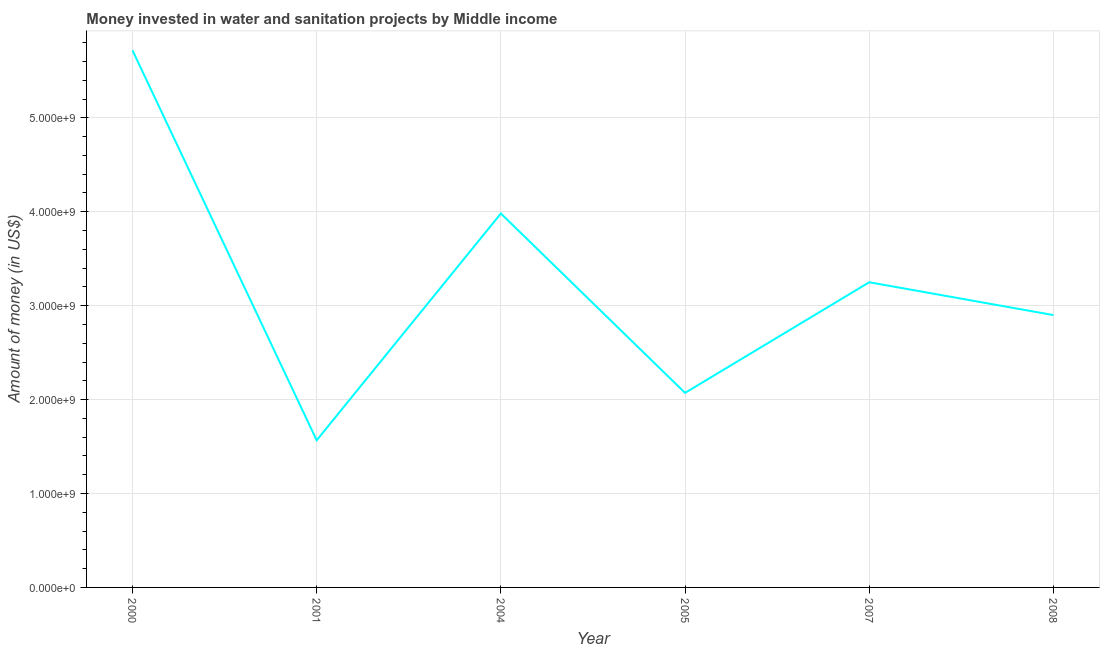What is the investment in 2005?
Your answer should be very brief. 2.07e+09. Across all years, what is the maximum investment?
Your answer should be very brief. 5.72e+09. Across all years, what is the minimum investment?
Provide a short and direct response. 1.57e+09. What is the sum of the investment?
Provide a short and direct response. 1.95e+1. What is the difference between the investment in 2001 and 2004?
Your response must be concise. -2.41e+09. What is the average investment per year?
Give a very brief answer. 3.25e+09. What is the median investment?
Keep it short and to the point. 3.07e+09. In how many years, is the investment greater than 3400000000 US$?
Provide a short and direct response. 2. What is the ratio of the investment in 2005 to that in 2007?
Provide a short and direct response. 0.64. Is the investment in 2000 less than that in 2005?
Give a very brief answer. No. What is the difference between the highest and the second highest investment?
Give a very brief answer. 1.74e+09. What is the difference between the highest and the lowest investment?
Offer a very short reply. 4.15e+09. How many lines are there?
Ensure brevity in your answer.  1. What is the difference between two consecutive major ticks on the Y-axis?
Your answer should be very brief. 1.00e+09. Are the values on the major ticks of Y-axis written in scientific E-notation?
Offer a terse response. Yes. Does the graph contain any zero values?
Provide a succinct answer. No. Does the graph contain grids?
Provide a short and direct response. Yes. What is the title of the graph?
Ensure brevity in your answer.  Money invested in water and sanitation projects by Middle income. What is the label or title of the Y-axis?
Provide a short and direct response. Amount of money (in US$). What is the Amount of money (in US$) in 2000?
Your answer should be compact. 5.72e+09. What is the Amount of money (in US$) in 2001?
Your response must be concise. 1.57e+09. What is the Amount of money (in US$) in 2004?
Make the answer very short. 3.98e+09. What is the Amount of money (in US$) in 2005?
Provide a short and direct response. 2.07e+09. What is the Amount of money (in US$) in 2007?
Provide a succinct answer. 3.25e+09. What is the Amount of money (in US$) of 2008?
Provide a short and direct response. 2.90e+09. What is the difference between the Amount of money (in US$) in 2000 and 2001?
Offer a terse response. 4.15e+09. What is the difference between the Amount of money (in US$) in 2000 and 2004?
Your response must be concise. 1.74e+09. What is the difference between the Amount of money (in US$) in 2000 and 2005?
Ensure brevity in your answer.  3.65e+09. What is the difference between the Amount of money (in US$) in 2000 and 2007?
Make the answer very short. 2.47e+09. What is the difference between the Amount of money (in US$) in 2000 and 2008?
Keep it short and to the point. 2.82e+09. What is the difference between the Amount of money (in US$) in 2001 and 2004?
Ensure brevity in your answer.  -2.41e+09. What is the difference between the Amount of money (in US$) in 2001 and 2005?
Your answer should be compact. -5.05e+08. What is the difference between the Amount of money (in US$) in 2001 and 2007?
Your answer should be compact. -1.68e+09. What is the difference between the Amount of money (in US$) in 2001 and 2008?
Your answer should be very brief. -1.33e+09. What is the difference between the Amount of money (in US$) in 2004 and 2005?
Your answer should be compact. 1.91e+09. What is the difference between the Amount of money (in US$) in 2004 and 2007?
Offer a terse response. 7.32e+08. What is the difference between the Amount of money (in US$) in 2004 and 2008?
Make the answer very short. 1.08e+09. What is the difference between the Amount of money (in US$) in 2005 and 2007?
Your answer should be compact. -1.18e+09. What is the difference between the Amount of money (in US$) in 2005 and 2008?
Make the answer very short. -8.28e+08. What is the difference between the Amount of money (in US$) in 2007 and 2008?
Your answer should be compact. 3.50e+08. What is the ratio of the Amount of money (in US$) in 2000 to that in 2001?
Make the answer very short. 3.65. What is the ratio of the Amount of money (in US$) in 2000 to that in 2004?
Your answer should be very brief. 1.44. What is the ratio of the Amount of money (in US$) in 2000 to that in 2005?
Keep it short and to the point. 2.76. What is the ratio of the Amount of money (in US$) in 2000 to that in 2007?
Give a very brief answer. 1.76. What is the ratio of the Amount of money (in US$) in 2000 to that in 2008?
Keep it short and to the point. 1.97. What is the ratio of the Amount of money (in US$) in 2001 to that in 2004?
Make the answer very short. 0.39. What is the ratio of the Amount of money (in US$) in 2001 to that in 2005?
Your answer should be compact. 0.76. What is the ratio of the Amount of money (in US$) in 2001 to that in 2007?
Ensure brevity in your answer.  0.48. What is the ratio of the Amount of money (in US$) in 2001 to that in 2008?
Provide a short and direct response. 0.54. What is the ratio of the Amount of money (in US$) in 2004 to that in 2005?
Your answer should be compact. 1.92. What is the ratio of the Amount of money (in US$) in 2004 to that in 2007?
Provide a short and direct response. 1.23. What is the ratio of the Amount of money (in US$) in 2004 to that in 2008?
Provide a short and direct response. 1.37. What is the ratio of the Amount of money (in US$) in 2005 to that in 2007?
Give a very brief answer. 0.64. What is the ratio of the Amount of money (in US$) in 2005 to that in 2008?
Offer a very short reply. 0.71. What is the ratio of the Amount of money (in US$) in 2007 to that in 2008?
Keep it short and to the point. 1.12. 